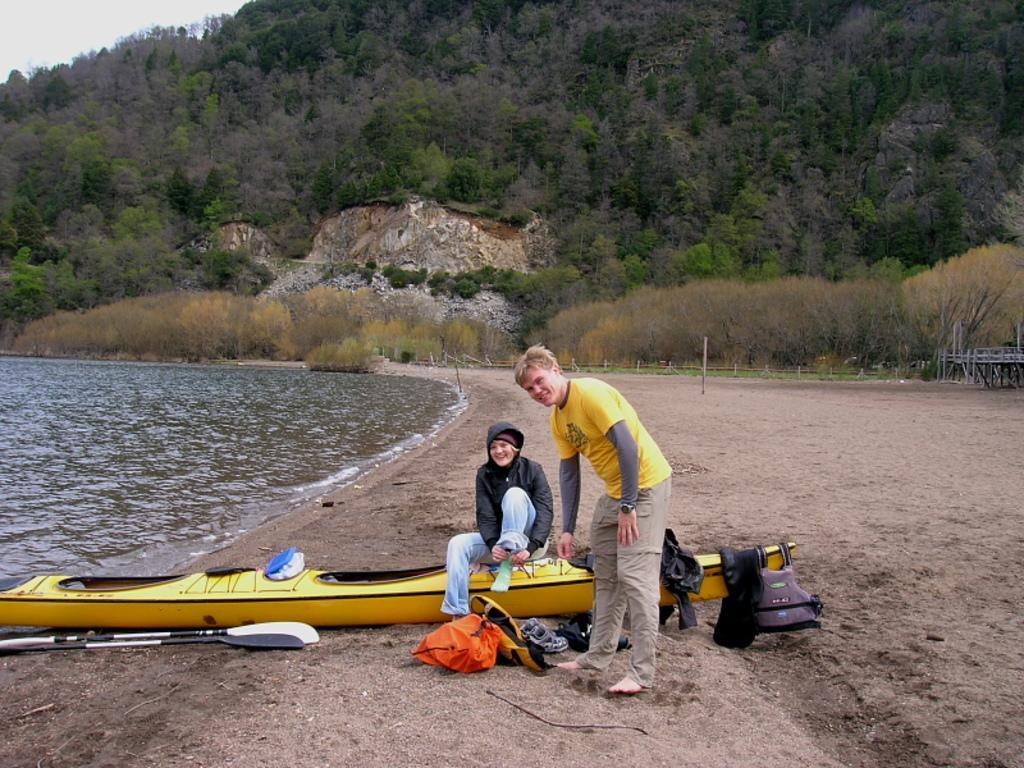Please provide a concise description of this image. In this image we can see this person wearing a yellow color t-shirt is standing on the sand and this person wearing black jacket is sitting on the yellow color boat which is kept on the sand. Here we can see paddles, and we can see some objects, we can see water, plants, trees on the hills and the sky in the background. 